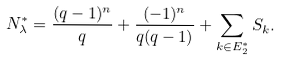Convert formula to latex. <formula><loc_0><loc_0><loc_500><loc_500>N _ { \lambda } ^ { * } = \frac { ( q - 1 ) ^ { n } } { q } + \frac { ( - 1 ) ^ { n } } { q ( q - 1 ) } + \sum _ { k \in E _ { 2 } ^ { * } } S _ { k } .</formula> 